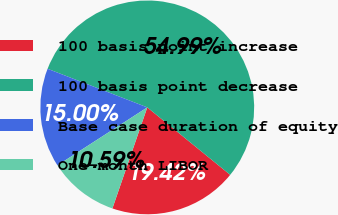Convert chart. <chart><loc_0><loc_0><loc_500><loc_500><pie_chart><fcel>100 basis point increase<fcel>100 basis point decrease<fcel>Base case duration of equity<fcel>One-month LIBOR<nl><fcel>19.42%<fcel>54.99%<fcel>15.0%<fcel>10.59%<nl></chart> 